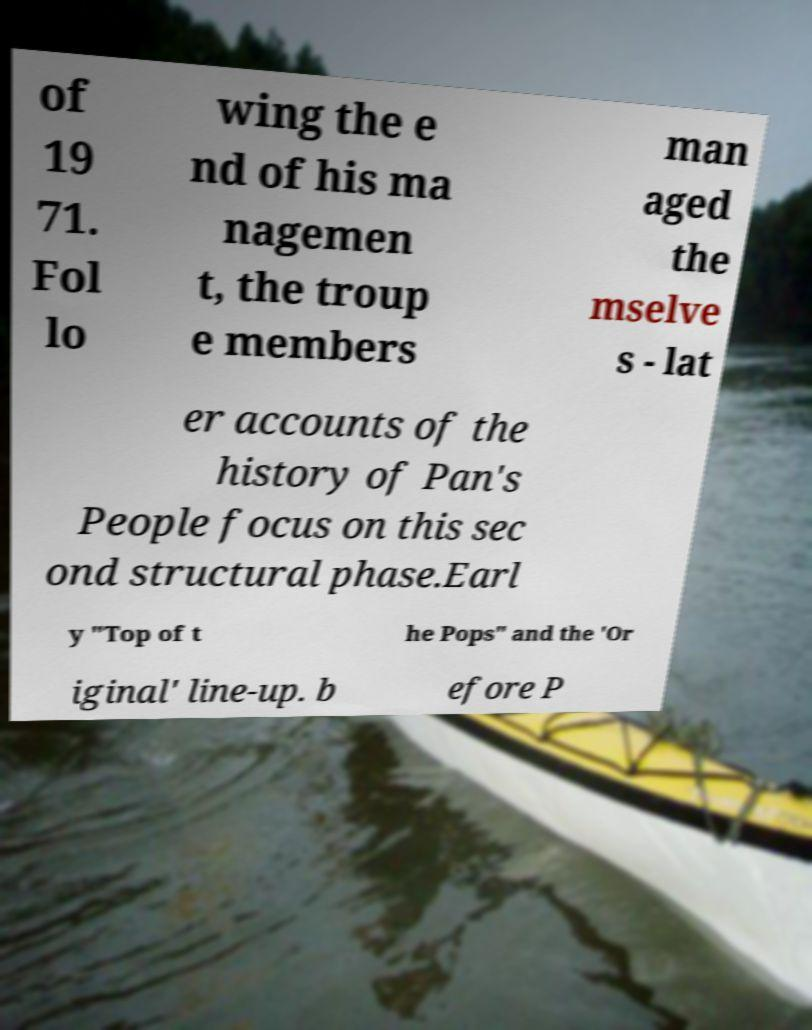Could you assist in decoding the text presented in this image and type it out clearly? of 19 71. Fol lo wing the e nd of his ma nagemen t, the troup e members man aged the mselve s - lat er accounts of the history of Pan's People focus on this sec ond structural phase.Earl y "Top of t he Pops" and the 'Or iginal' line-up. b efore P 